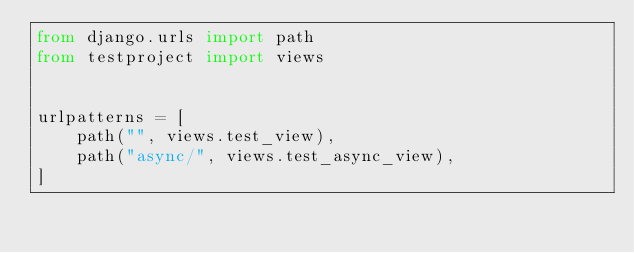<code> <loc_0><loc_0><loc_500><loc_500><_Python_>from django.urls import path
from testproject import views


urlpatterns = [
    path("", views.test_view),
    path("async/", views.test_async_view),
]
</code> 